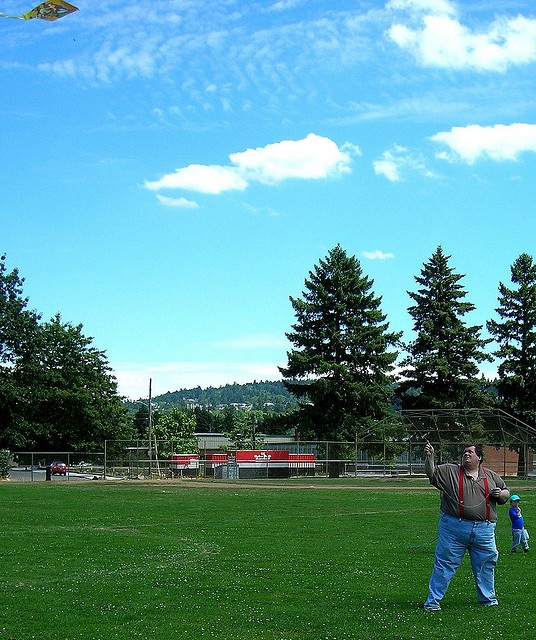Describe the objects in this image and their specific colors. I can see people in lightblue, black, gray, blue, and navy tones, kite in lightblue, gray, olive, black, and teal tones, people in lightblue, navy, black, blue, and darkblue tones, and car in lightblue, black, maroon, and gray tones in this image. 